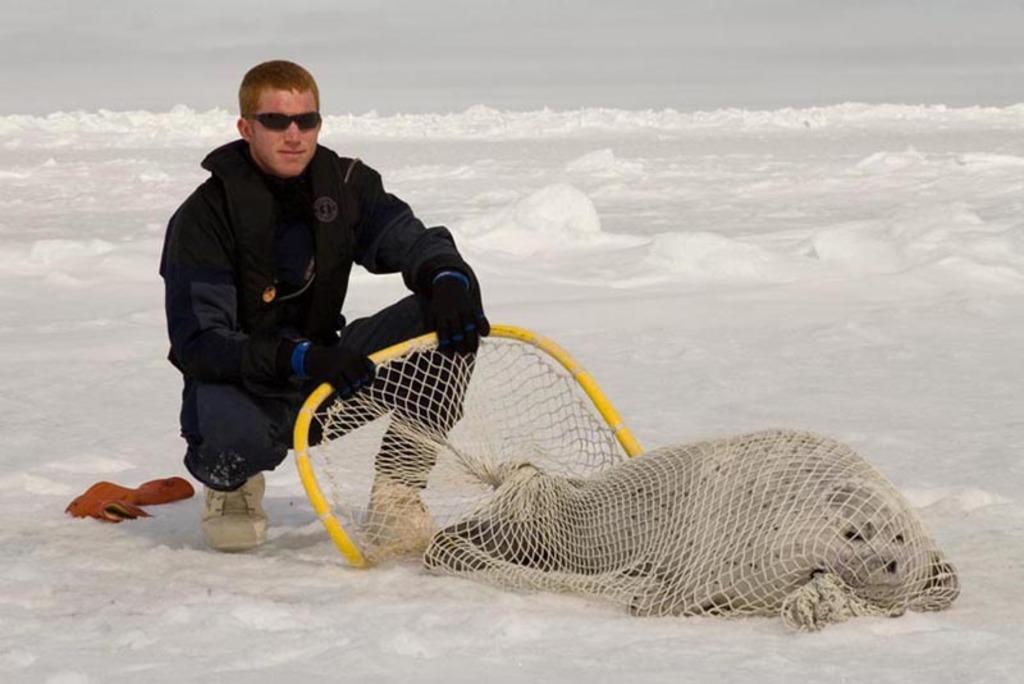Describe this image in one or two sentences. By seeing this image we can say a person is sitting on the mounds of snow and caught an animal in the nest. 